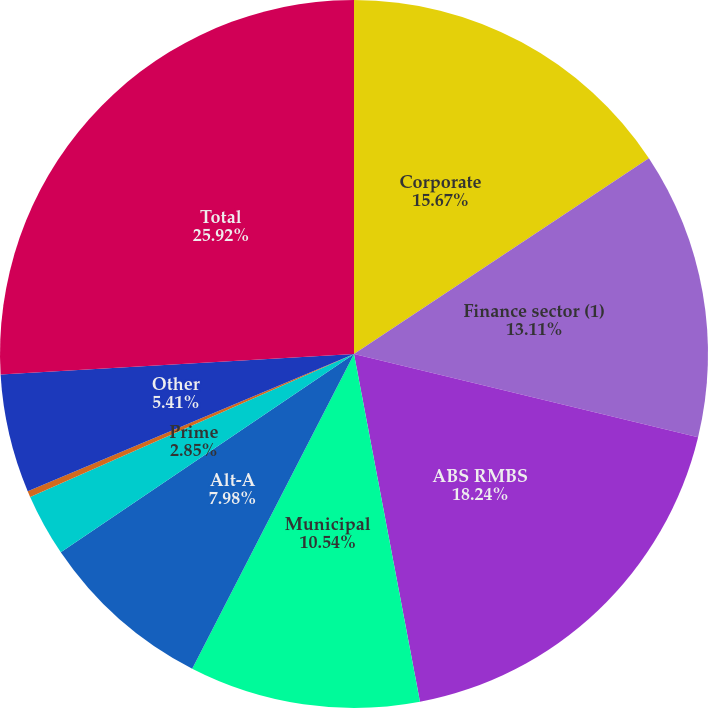Convert chart to OTSL. <chart><loc_0><loc_0><loc_500><loc_500><pie_chart><fcel>Corporate<fcel>Finance sector (1)<fcel>ABS RMBS<fcel>Municipal<fcel>Alt-A<fcel>Prime<fcel>Corporate privately placed<fcel>Other<fcel>Total<nl><fcel>15.67%<fcel>13.11%<fcel>18.24%<fcel>10.54%<fcel>7.98%<fcel>2.85%<fcel>0.28%<fcel>5.41%<fcel>25.93%<nl></chart> 